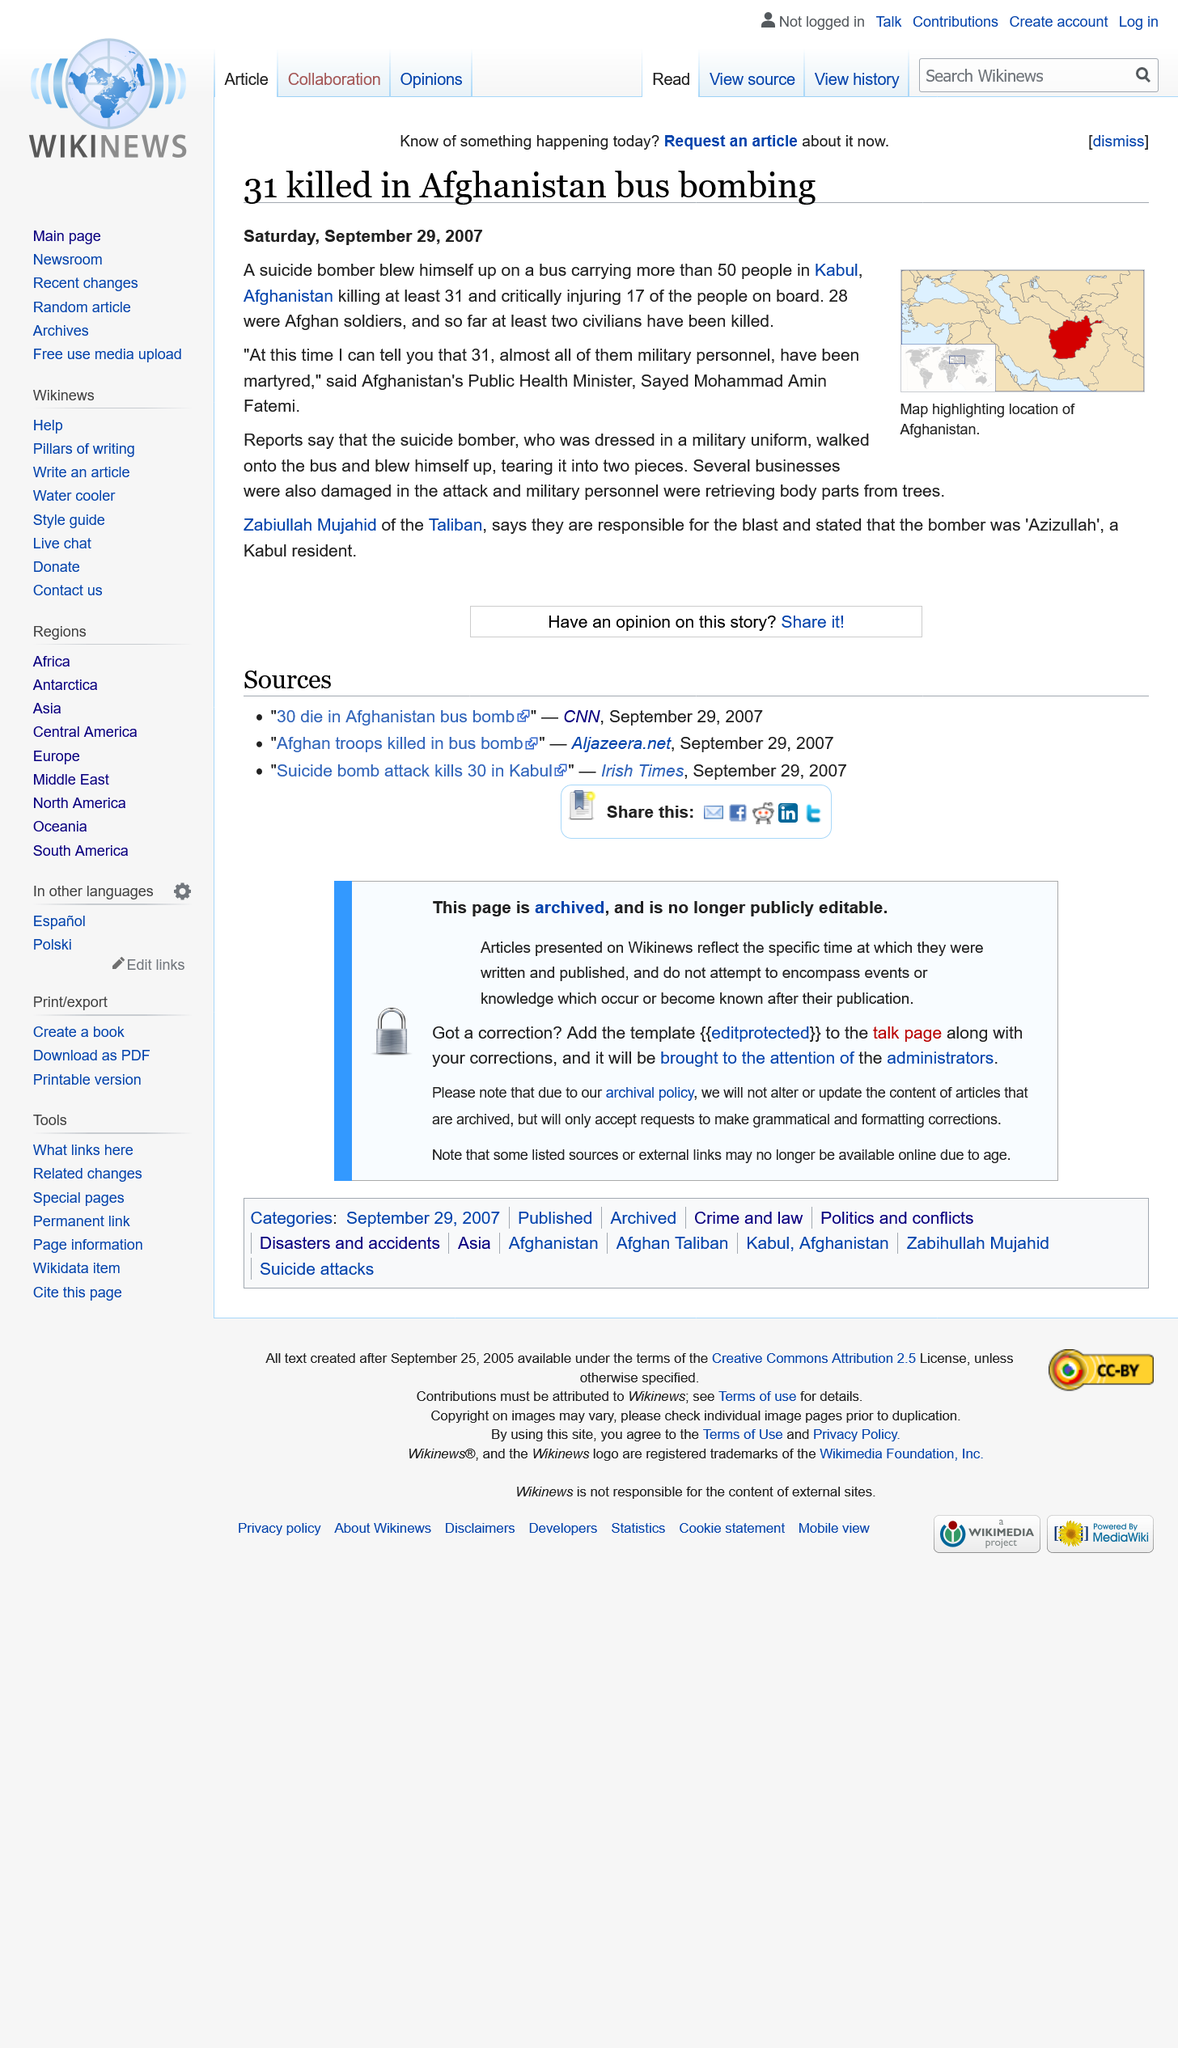Give some essential details in this illustration. The Taliban has claimed responsibility for the bombing, and thus it is known that this group was behind the attack. On Thursday, a bus bombing took place in Kabul, Afghanistan, which resulted in numerous casualties. The country shown in red on the map is Afghanistan, and it is the country that is being referred to in the sentence. 